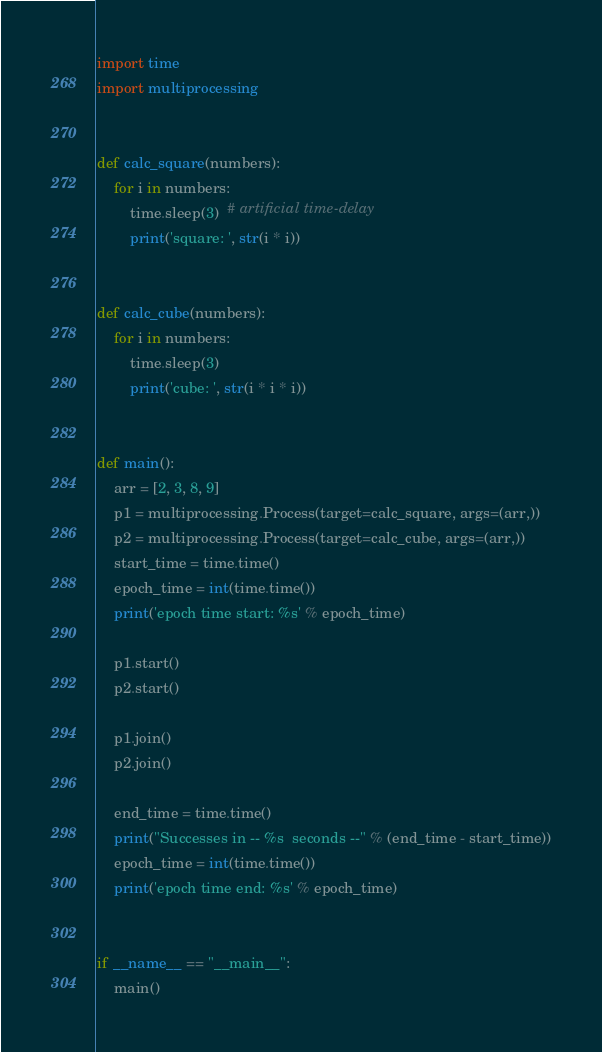Convert code to text. <code><loc_0><loc_0><loc_500><loc_500><_Python_>import time
import multiprocessing


def calc_square(numbers):
    for i in numbers:
        time.sleep(3)  # artificial time-delay
        print('square: ', str(i * i))


def calc_cube(numbers):
    for i in numbers:
        time.sleep(3)
        print('cube: ', str(i * i * i))


def main():
    arr = [2, 3, 8, 9]
    p1 = multiprocessing.Process(target=calc_square, args=(arr,))
    p2 = multiprocessing.Process(target=calc_cube, args=(arr,))
    start_time = time.time()
    epoch_time = int(time.time())
    print('epoch time start: %s' % epoch_time)

    p1.start()
    p2.start()

    p1.join()
    p2.join()

    end_time = time.time()
    print("Successes in -- %s  seconds --" % (end_time - start_time))
    epoch_time = int(time.time())
    print('epoch time end: %s' % epoch_time)


if __name__ == "__main__":
    main()
</code> 